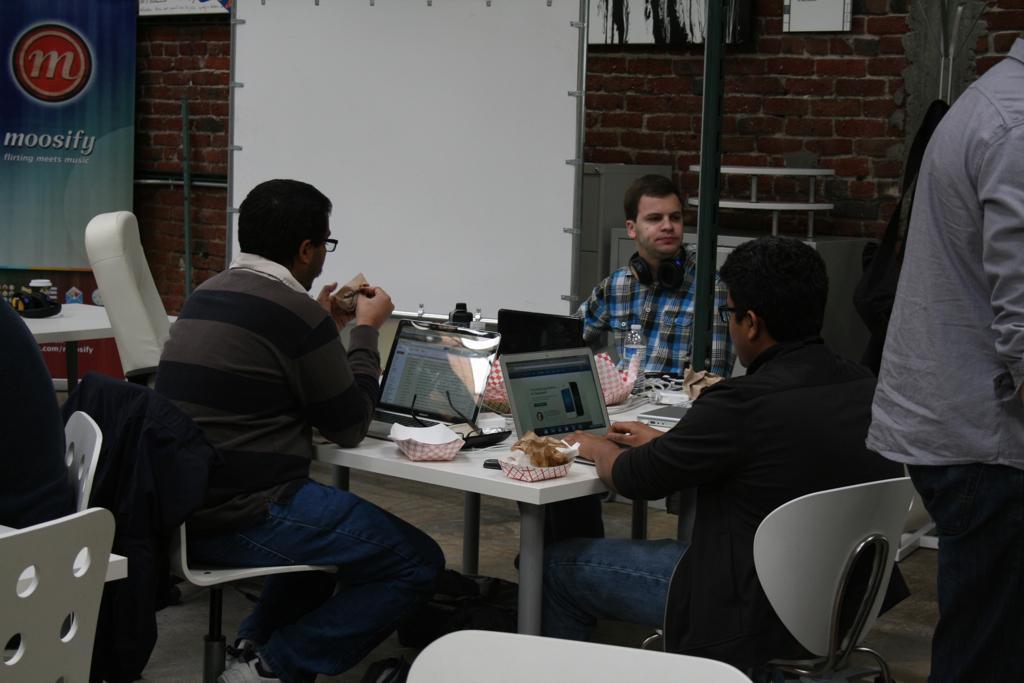How would you summarize this image in a sentence or two? In this image there are group of persons sitting on a chair and standing. The person at the center sitting on a wheelchair is doing some work on the laptop which is on the table. On the table there are laptops, papers. In the background there is a white board, red colour bricks, pole, banner, table. At the right side the person is standing. 